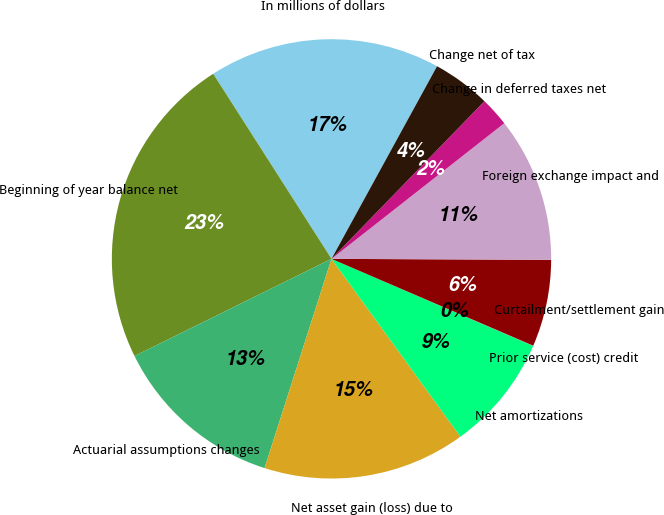<chart> <loc_0><loc_0><loc_500><loc_500><pie_chart><fcel>In millions of dollars<fcel>Beginning of year balance net<fcel>Actuarial assumptions changes<fcel>Net asset gain (loss) due to<fcel>Net amortizations<fcel>Prior service (cost) credit<fcel>Curtailment/settlement gain<fcel>Foreign exchange impact and<fcel>Change in deferred taxes net<fcel>Change net of tax<nl><fcel>17.03%<fcel>23.24%<fcel>12.78%<fcel>14.91%<fcel>8.53%<fcel>0.02%<fcel>6.4%<fcel>10.66%<fcel>2.15%<fcel>4.28%<nl></chart> 